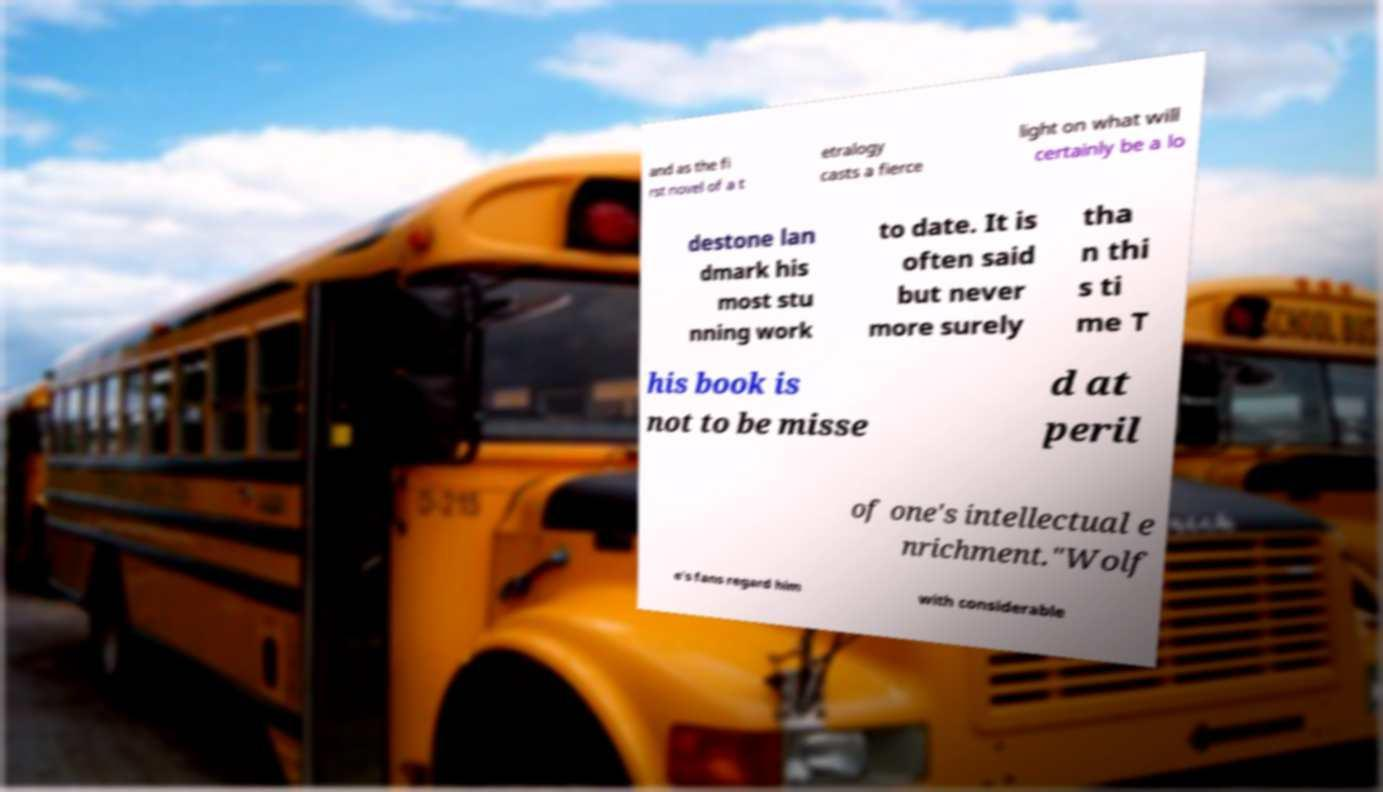Please read and relay the text visible in this image. What does it say? and as the fi rst novel of a t etralogy casts a fierce light on what will certainly be a lo destone lan dmark his most stu nning work to date. It is often said but never more surely tha n thi s ti me T his book is not to be misse d at peril of one's intellectual e nrichment."Wolf e's fans regard him with considerable 